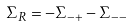Convert formula to latex. <formula><loc_0><loc_0><loc_500><loc_500>\Sigma _ { R } = - \Sigma _ { - + } - \Sigma _ { - - }</formula> 